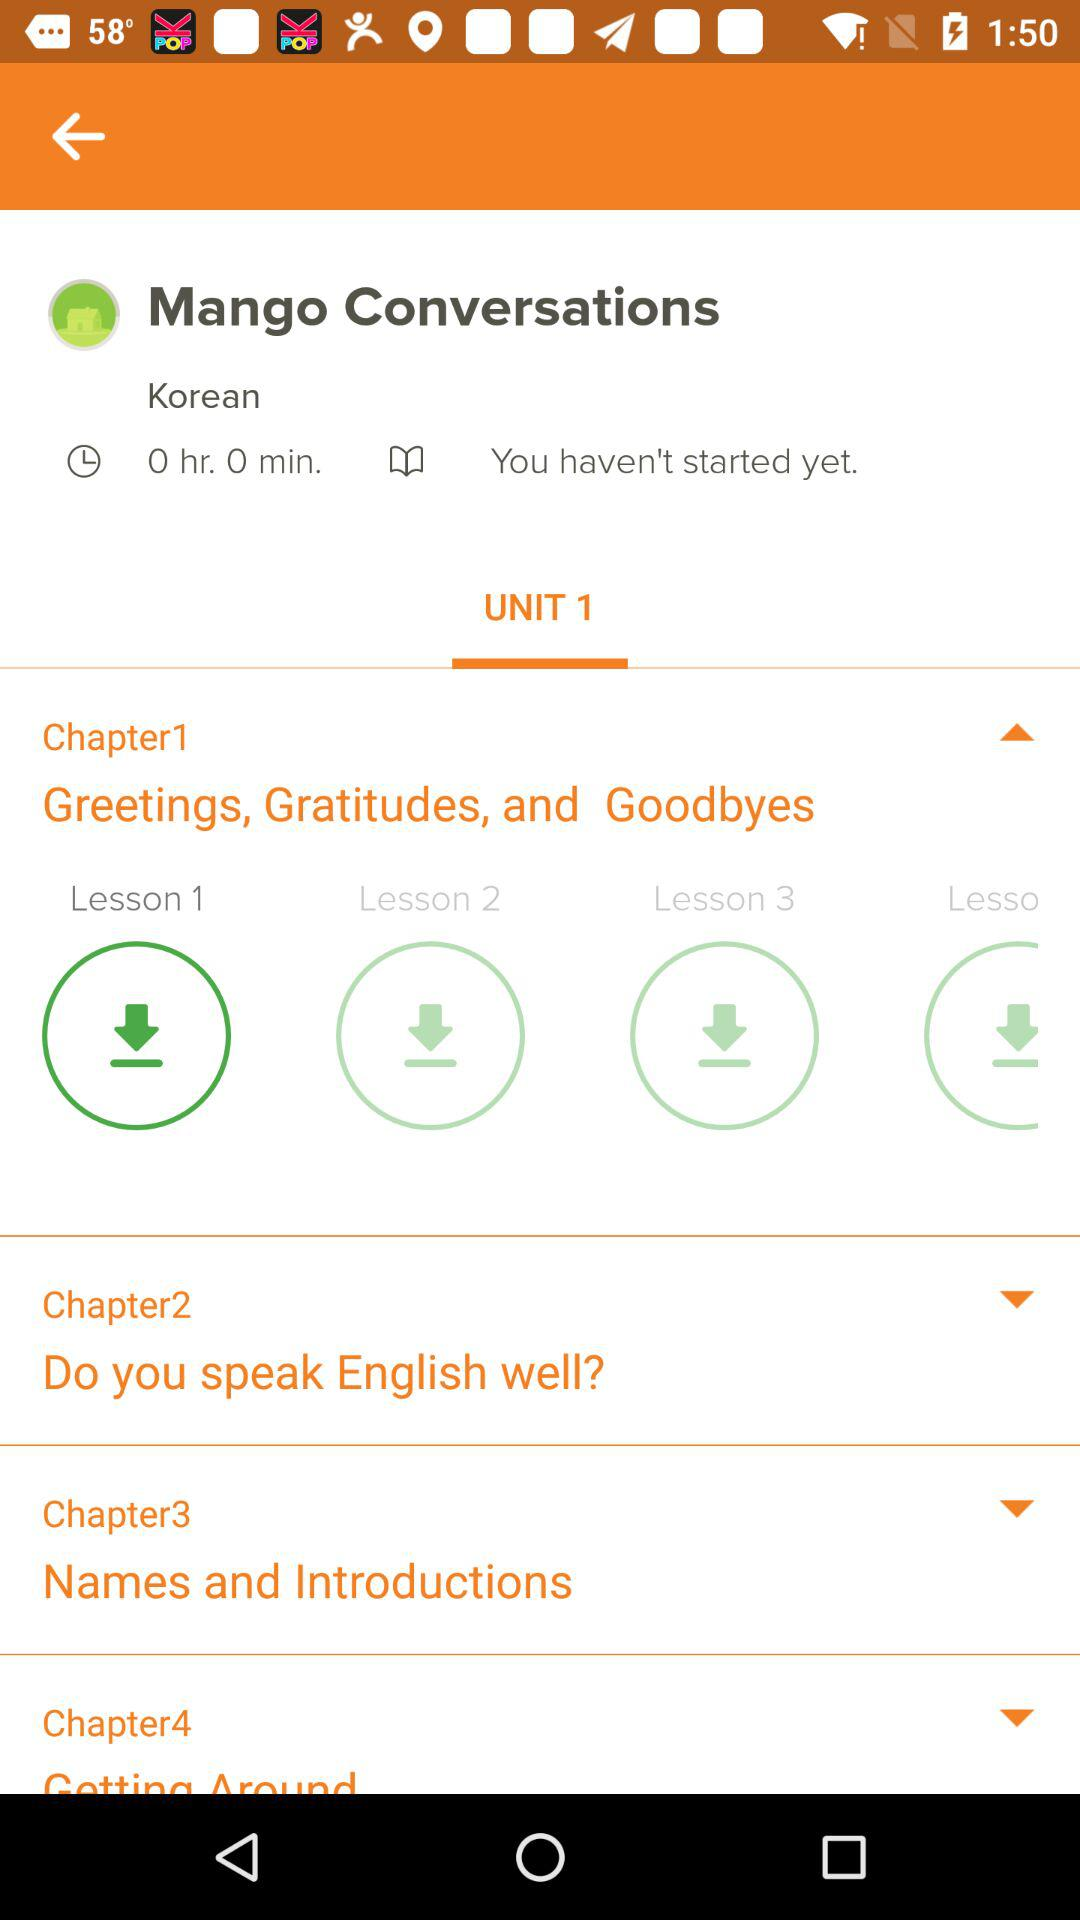Are there any cultural insights provided in this chapter? Although I cannot see the content of Chapter 1, typically, such chapters not only teach the language but also offer insights on the appropriate use of these expressions in different cultural contexts. This could include when to use certain greetings and goodbyes, or how to show gratitude in a way that's culturally respectful. 